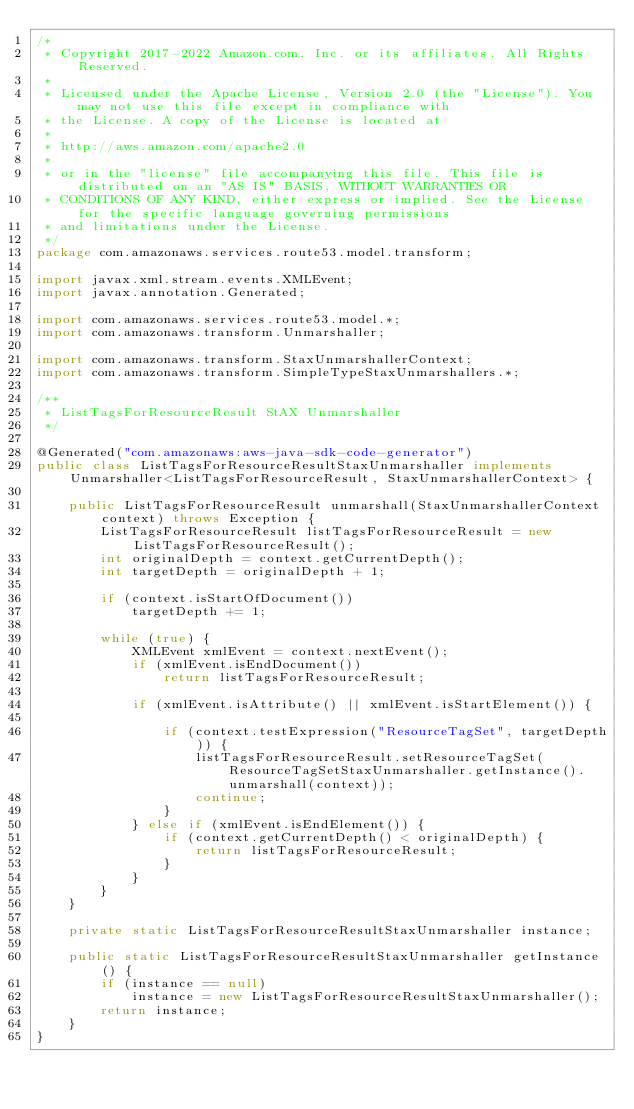<code> <loc_0><loc_0><loc_500><loc_500><_Java_>/*
 * Copyright 2017-2022 Amazon.com, Inc. or its affiliates. All Rights Reserved.
 * 
 * Licensed under the Apache License, Version 2.0 (the "License"). You may not use this file except in compliance with
 * the License. A copy of the License is located at
 * 
 * http://aws.amazon.com/apache2.0
 * 
 * or in the "license" file accompanying this file. This file is distributed on an "AS IS" BASIS, WITHOUT WARRANTIES OR
 * CONDITIONS OF ANY KIND, either express or implied. See the License for the specific language governing permissions
 * and limitations under the License.
 */
package com.amazonaws.services.route53.model.transform;

import javax.xml.stream.events.XMLEvent;
import javax.annotation.Generated;

import com.amazonaws.services.route53.model.*;
import com.amazonaws.transform.Unmarshaller;

import com.amazonaws.transform.StaxUnmarshallerContext;
import com.amazonaws.transform.SimpleTypeStaxUnmarshallers.*;

/**
 * ListTagsForResourceResult StAX Unmarshaller
 */

@Generated("com.amazonaws:aws-java-sdk-code-generator")
public class ListTagsForResourceResultStaxUnmarshaller implements Unmarshaller<ListTagsForResourceResult, StaxUnmarshallerContext> {

    public ListTagsForResourceResult unmarshall(StaxUnmarshallerContext context) throws Exception {
        ListTagsForResourceResult listTagsForResourceResult = new ListTagsForResourceResult();
        int originalDepth = context.getCurrentDepth();
        int targetDepth = originalDepth + 1;

        if (context.isStartOfDocument())
            targetDepth += 1;

        while (true) {
            XMLEvent xmlEvent = context.nextEvent();
            if (xmlEvent.isEndDocument())
                return listTagsForResourceResult;

            if (xmlEvent.isAttribute() || xmlEvent.isStartElement()) {

                if (context.testExpression("ResourceTagSet", targetDepth)) {
                    listTagsForResourceResult.setResourceTagSet(ResourceTagSetStaxUnmarshaller.getInstance().unmarshall(context));
                    continue;
                }
            } else if (xmlEvent.isEndElement()) {
                if (context.getCurrentDepth() < originalDepth) {
                    return listTagsForResourceResult;
                }
            }
        }
    }

    private static ListTagsForResourceResultStaxUnmarshaller instance;

    public static ListTagsForResourceResultStaxUnmarshaller getInstance() {
        if (instance == null)
            instance = new ListTagsForResourceResultStaxUnmarshaller();
        return instance;
    }
}
</code> 